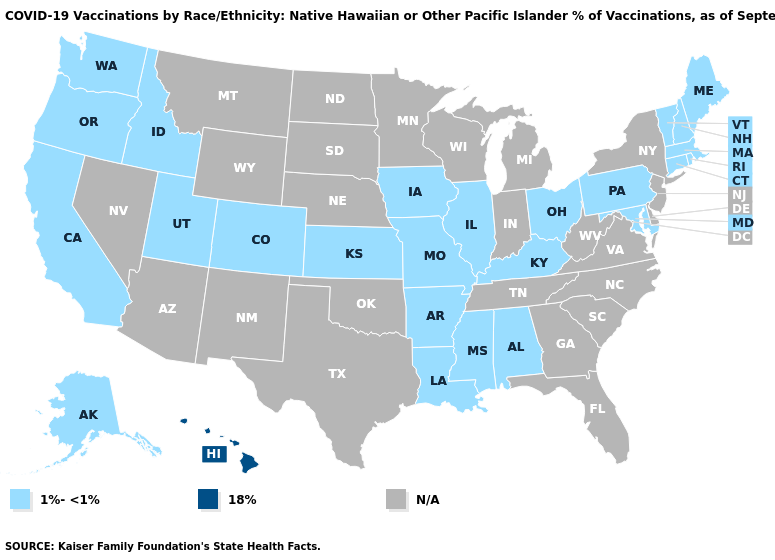What is the lowest value in the MidWest?
Quick response, please. 1%-<1%. Name the states that have a value in the range N/A?
Quick response, please. Arizona, Delaware, Florida, Georgia, Indiana, Michigan, Minnesota, Montana, Nebraska, Nevada, New Jersey, New Mexico, New York, North Carolina, North Dakota, Oklahoma, South Carolina, South Dakota, Tennessee, Texas, Virginia, West Virginia, Wisconsin, Wyoming. What is the highest value in states that border Oregon?
Short answer required. 1%-<1%. What is the value of Wyoming?
Quick response, please. N/A. Which states have the highest value in the USA?
Be succinct. Hawaii. What is the highest value in states that border Georgia?
Quick response, please. 1%-<1%. What is the value of Alabama?
Be succinct. 1%-<1%. What is the value of Arizona?
Concise answer only. N/A. Which states hav the highest value in the MidWest?
Quick response, please. Illinois, Iowa, Kansas, Missouri, Ohio. What is the lowest value in the USA?
Give a very brief answer. 1%-<1%. Which states have the lowest value in the USA?
Short answer required. Alabama, Alaska, Arkansas, California, Colorado, Connecticut, Idaho, Illinois, Iowa, Kansas, Kentucky, Louisiana, Maine, Maryland, Massachusetts, Mississippi, Missouri, New Hampshire, Ohio, Oregon, Pennsylvania, Rhode Island, Utah, Vermont, Washington. What is the value of Virginia?
Quick response, please. N/A. 